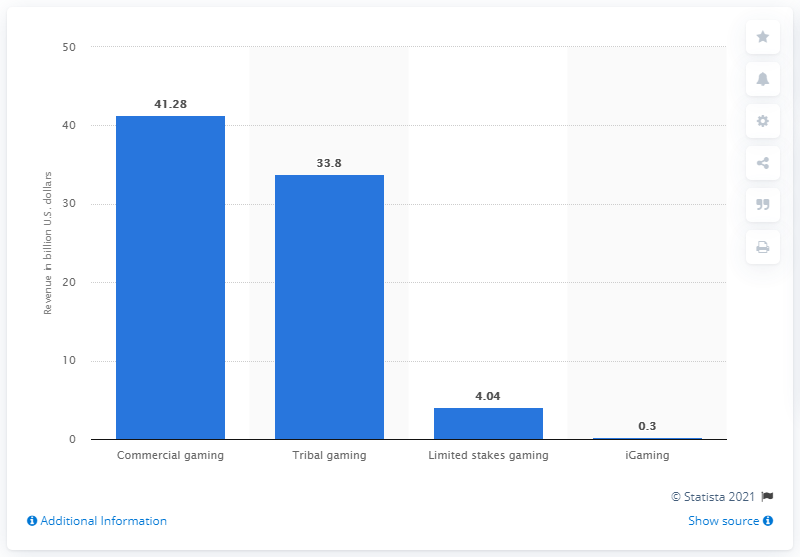List a handful of essential elements in this visual. In 2018, the commercial gaming industry generated approximately 41.28 billion U.S. dollars. 